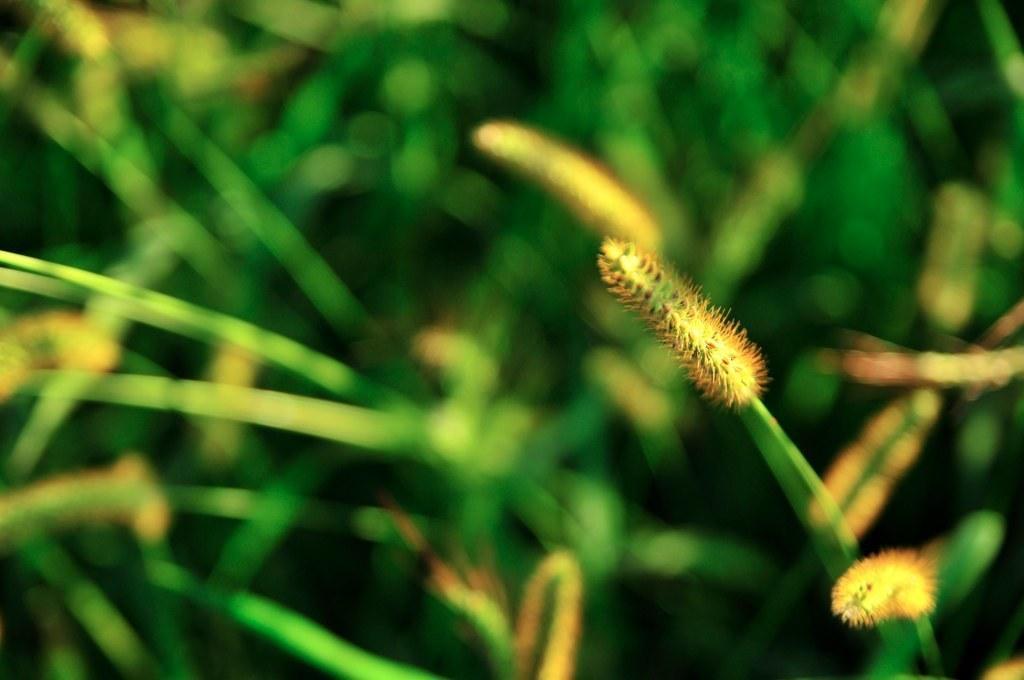Could you give a brief overview of what you see in this image? In the picture we can see some grass plants with some buds to it. 